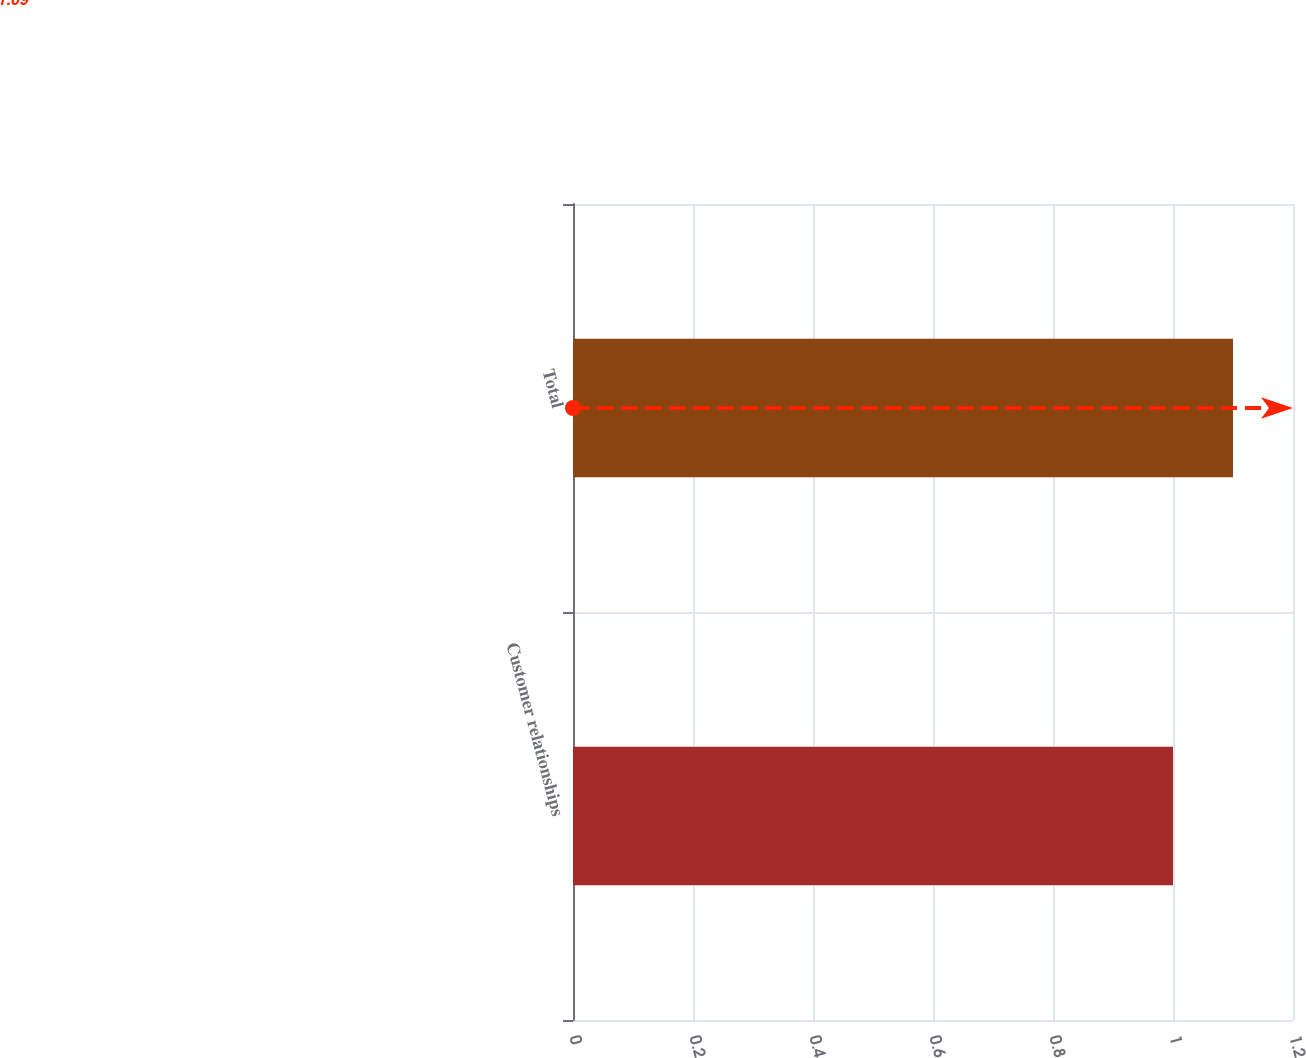Convert chart to OTSL. <chart><loc_0><loc_0><loc_500><loc_500><bar_chart><fcel>Customer relationships<fcel>Total<nl><fcel>1<fcel>1.1<nl></chart> 